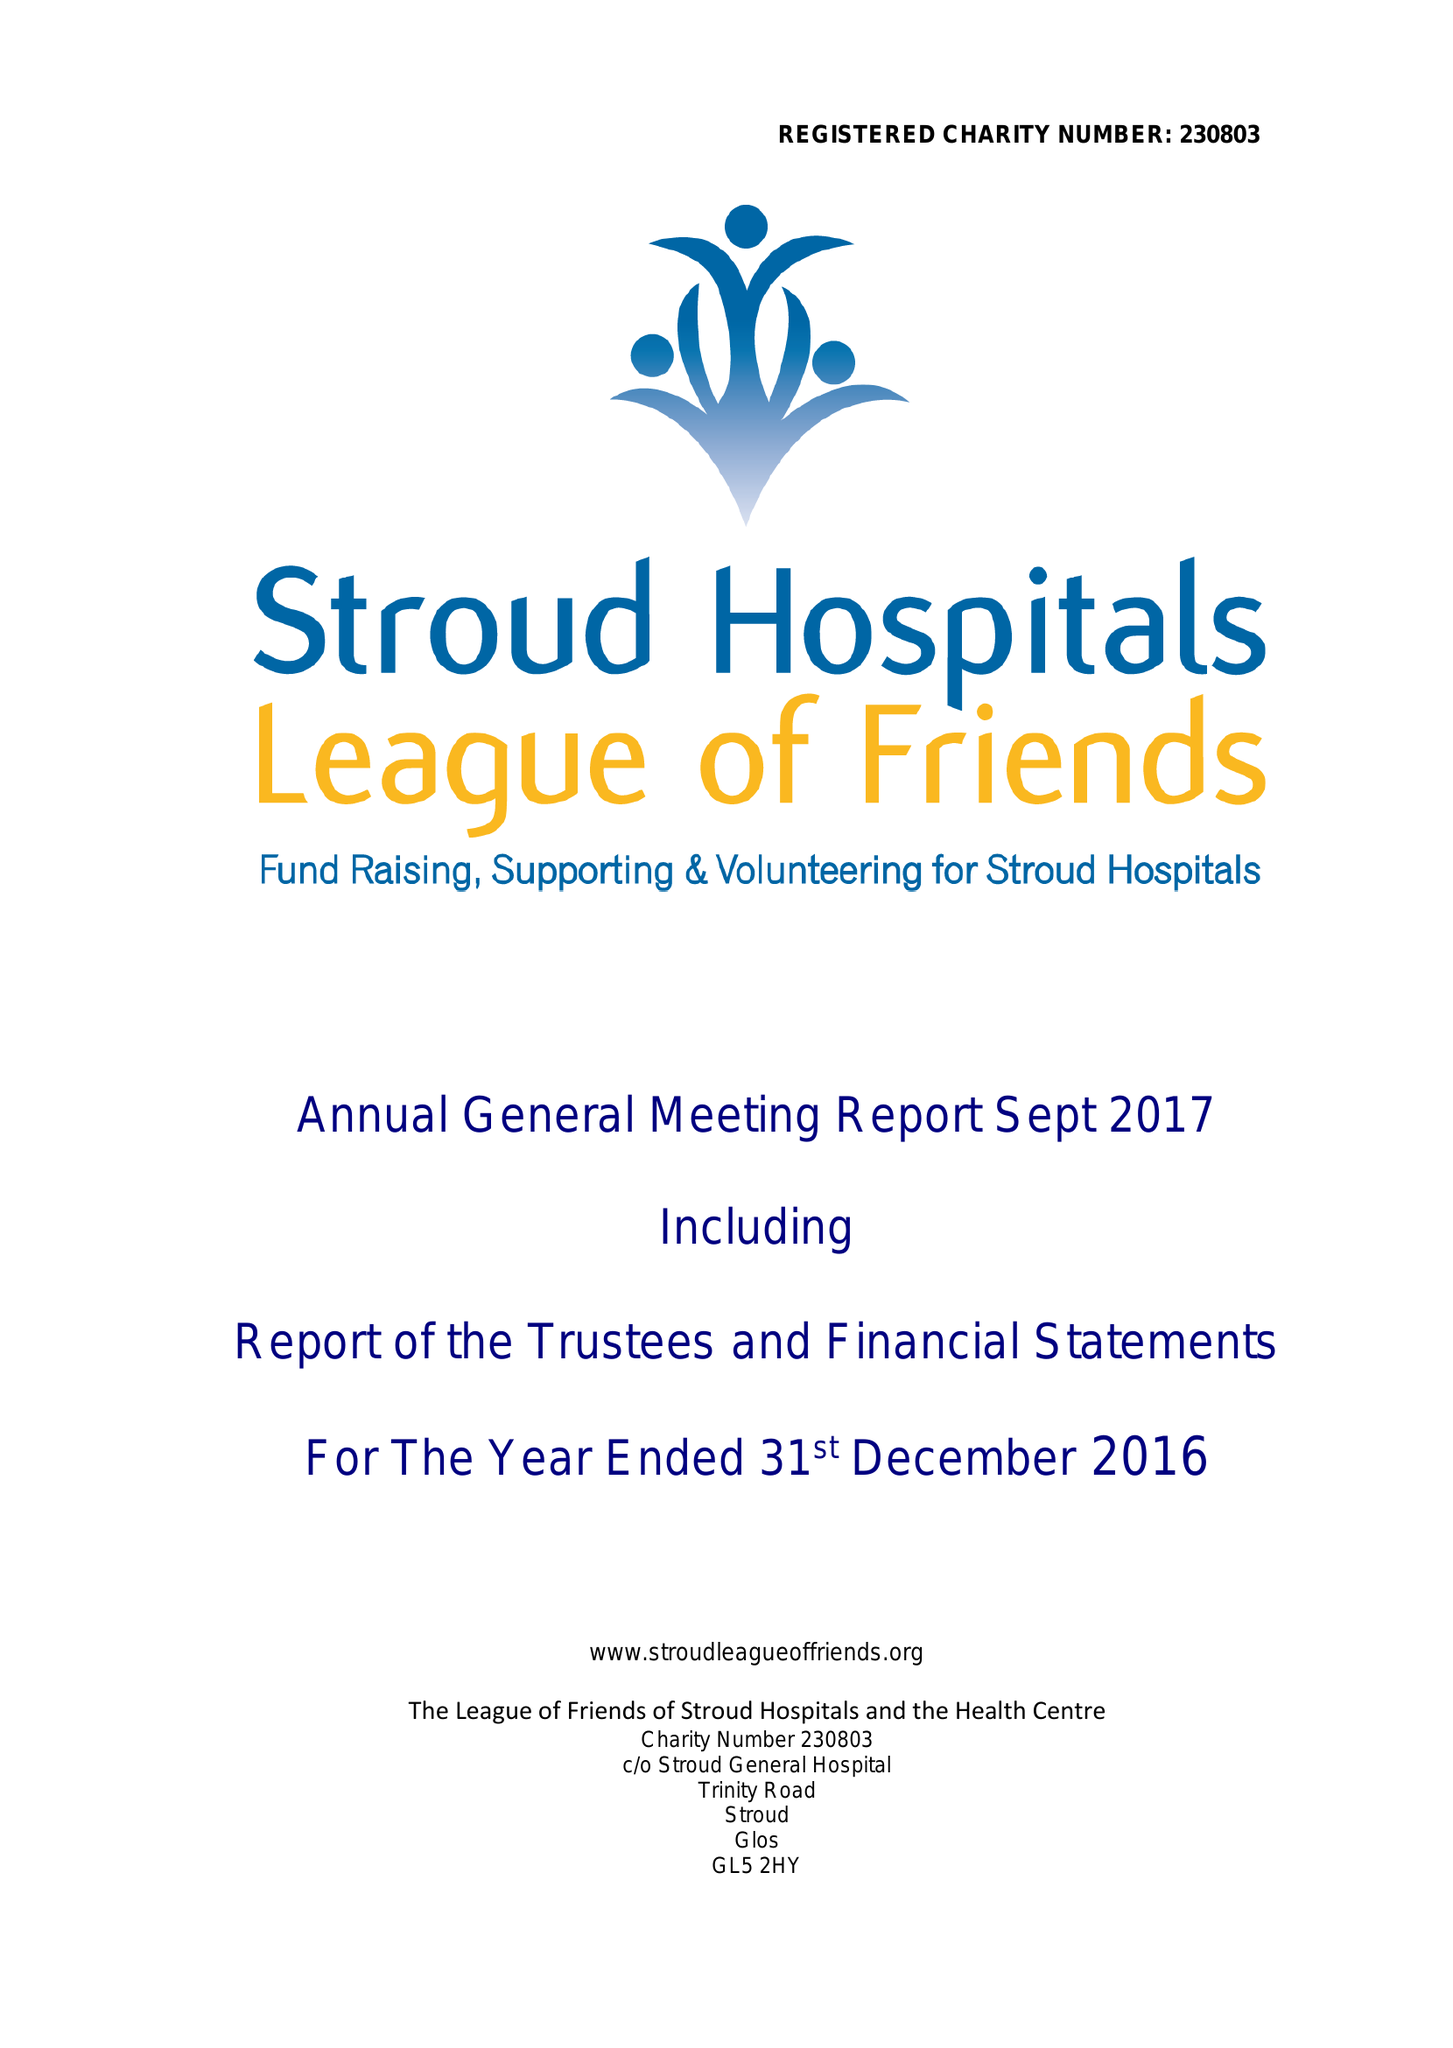What is the value for the spending_annually_in_british_pounds?
Answer the question using a single word or phrase. 300626.00 